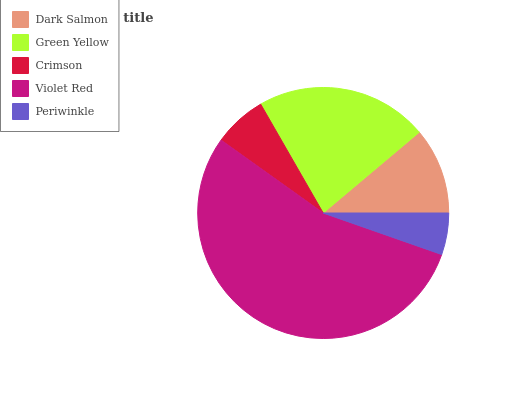Is Periwinkle the minimum?
Answer yes or no. Yes. Is Violet Red the maximum?
Answer yes or no. Yes. Is Green Yellow the minimum?
Answer yes or no. No. Is Green Yellow the maximum?
Answer yes or no. No. Is Green Yellow greater than Dark Salmon?
Answer yes or no. Yes. Is Dark Salmon less than Green Yellow?
Answer yes or no. Yes. Is Dark Salmon greater than Green Yellow?
Answer yes or no. No. Is Green Yellow less than Dark Salmon?
Answer yes or no. No. Is Dark Salmon the high median?
Answer yes or no. Yes. Is Dark Salmon the low median?
Answer yes or no. Yes. Is Green Yellow the high median?
Answer yes or no. No. Is Violet Red the low median?
Answer yes or no. No. 